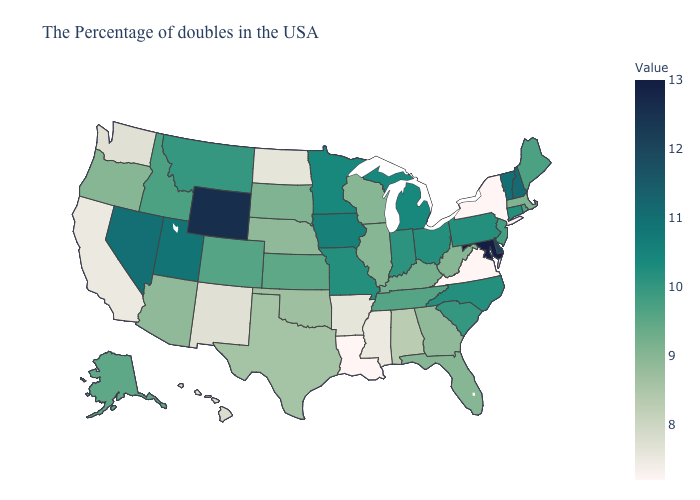Does Virginia have the lowest value in the USA?
Be succinct. Yes. Among the states that border Wisconsin , does Illinois have the lowest value?
Short answer required. Yes. Which states have the lowest value in the USA?
Keep it brief. New York, Virginia, Louisiana. Does Montana have a higher value than Florida?
Short answer required. Yes. Among the states that border Pennsylvania , does Maryland have the highest value?
Write a very short answer. Yes. Which states have the highest value in the USA?
Short answer required. Maryland. Among the states that border Wisconsin , which have the lowest value?
Quick response, please. Illinois. 